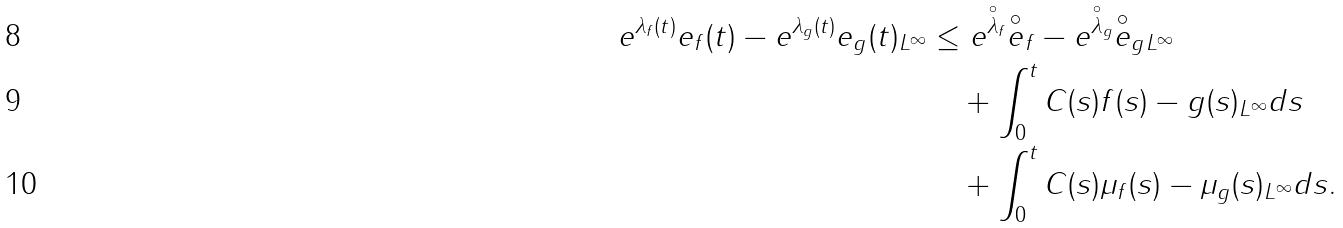<formula> <loc_0><loc_0><loc_500><loc_500>\| e ^ { \lambda _ { f } ( t ) } e _ { f } ( t ) - e ^ { \lambda _ { g } ( t ) } e _ { g } ( t ) \| _ { L ^ { \infty } } & \leq \| e ^ { \overset { \circ } { \lambda } _ { f } } \overset { \circ } { e } _ { f } - e ^ { \overset { \circ } { \lambda } _ { g } } \overset { \circ } { e } _ { g } \| _ { L ^ { \infty } } \\ & \quad + \int _ { 0 } ^ { t } C ( s ) \| f ( s ) - g ( s ) \| _ { L ^ { \infty } } d s \\ & \quad + \int _ { 0 } ^ { t } C ( s ) \| \mu _ { f } ( s ) - \mu _ { g } ( s ) \| _ { L ^ { \infty } } d s .</formula> 